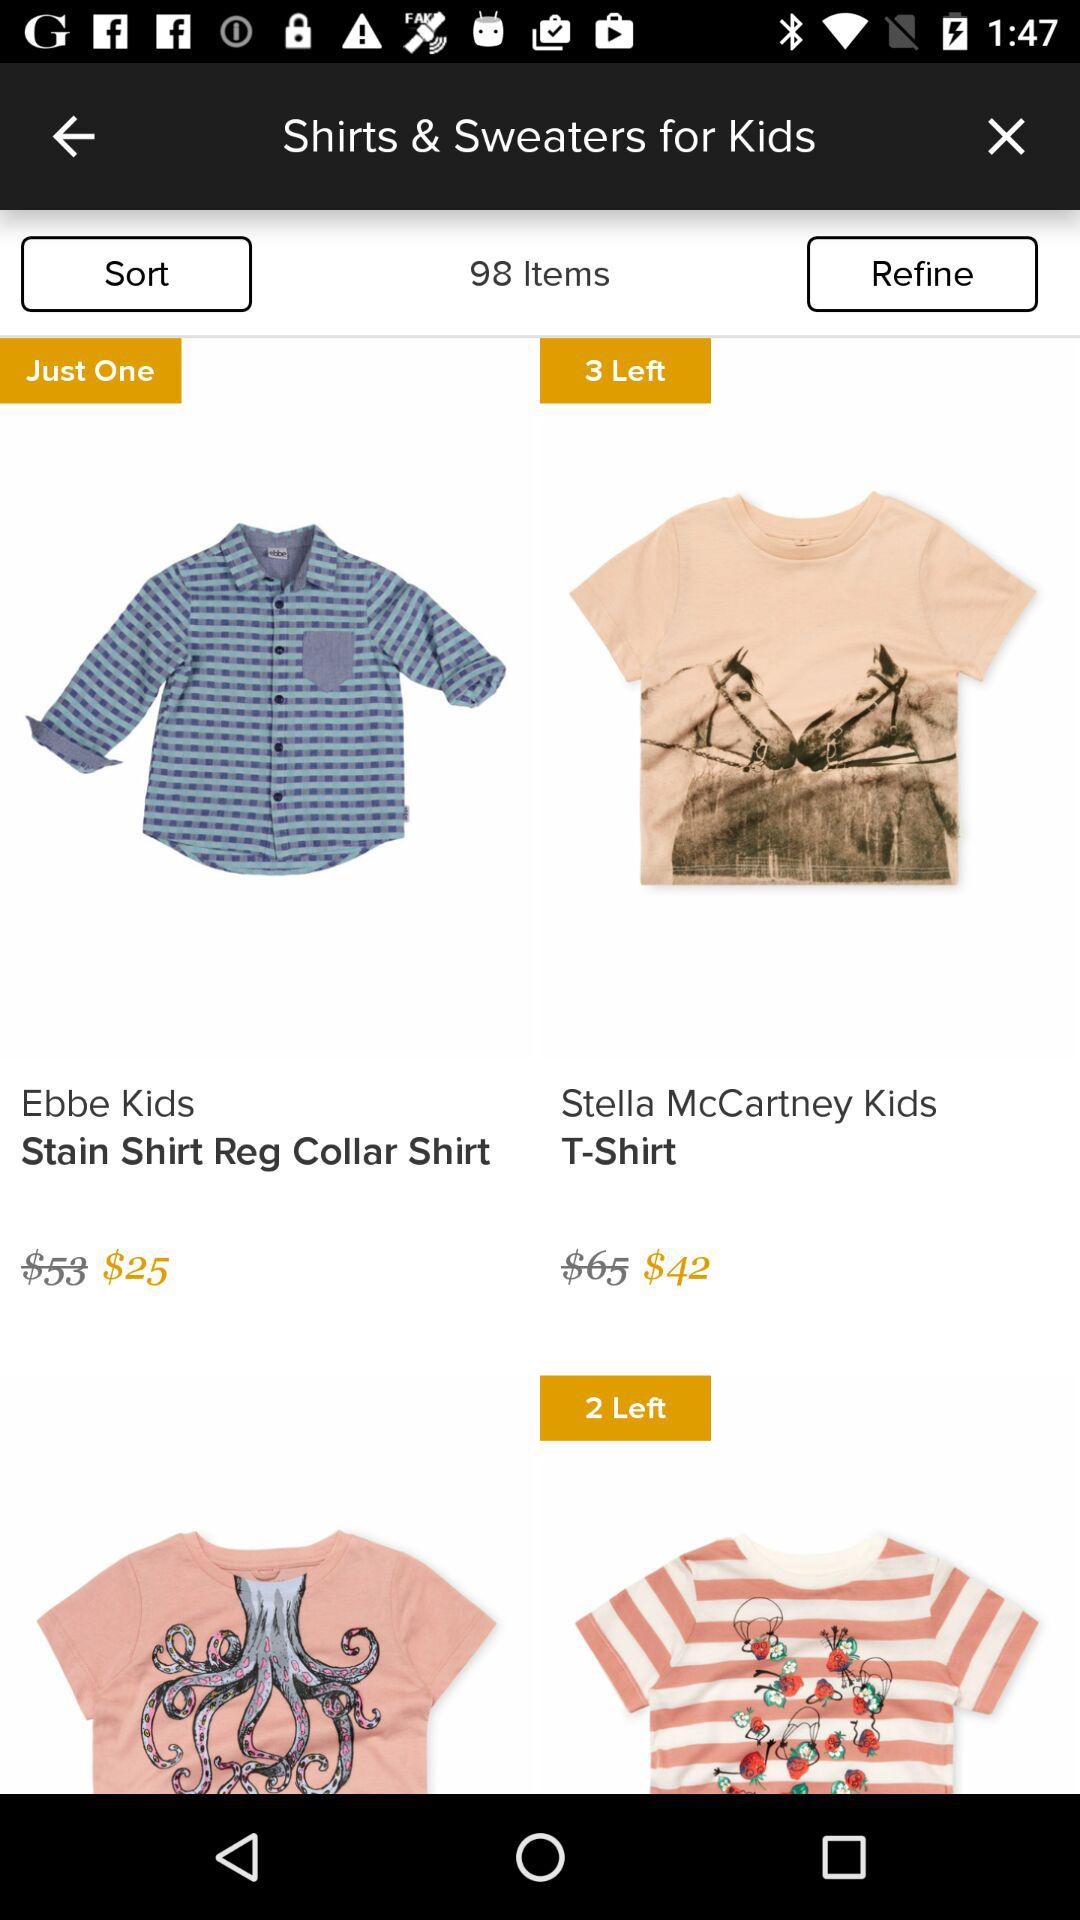What is the total number of items in this? There are 98 items. 